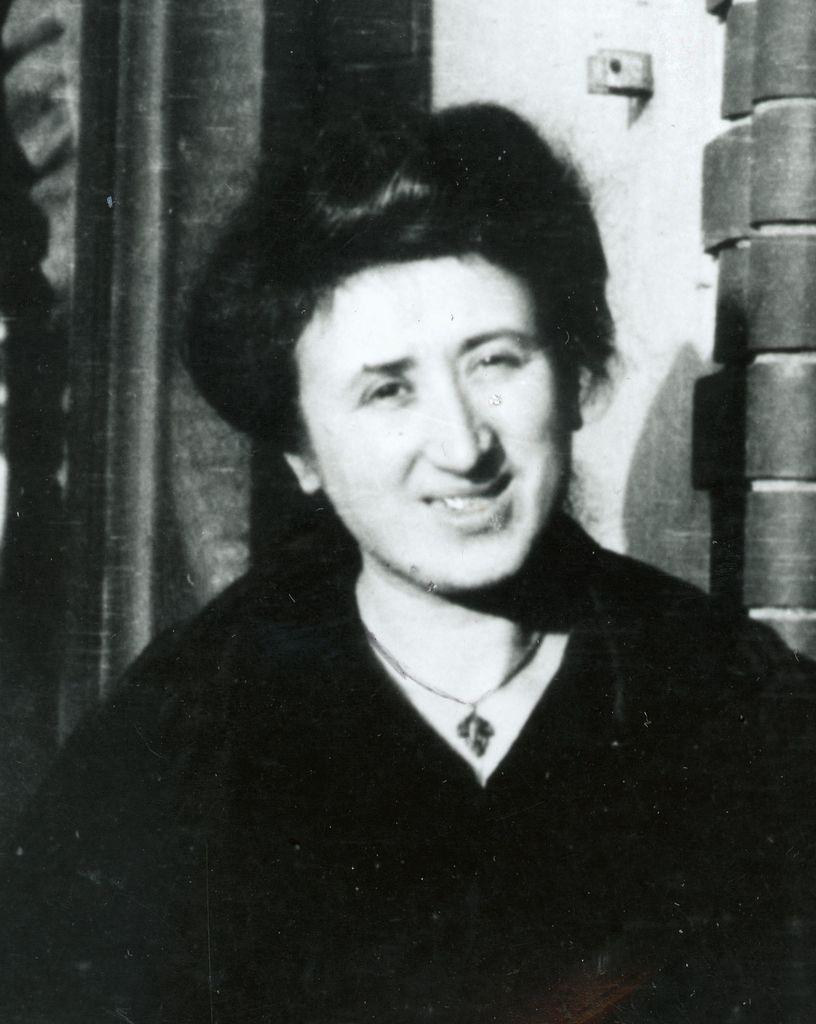What is the color scheme of the image? The image is black and white. Can you describe the main subject in the image? There is a person in the image. What can be seen in the background of the image? There is a wall and a pole in the background of the image, along with other objects. How many children are playing with the sock in the image? There are no children or socks present in the image. 